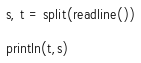<code> <loc_0><loc_0><loc_500><loc_500><_Julia_>s, t = split(readline())

println(t,s)</code> 